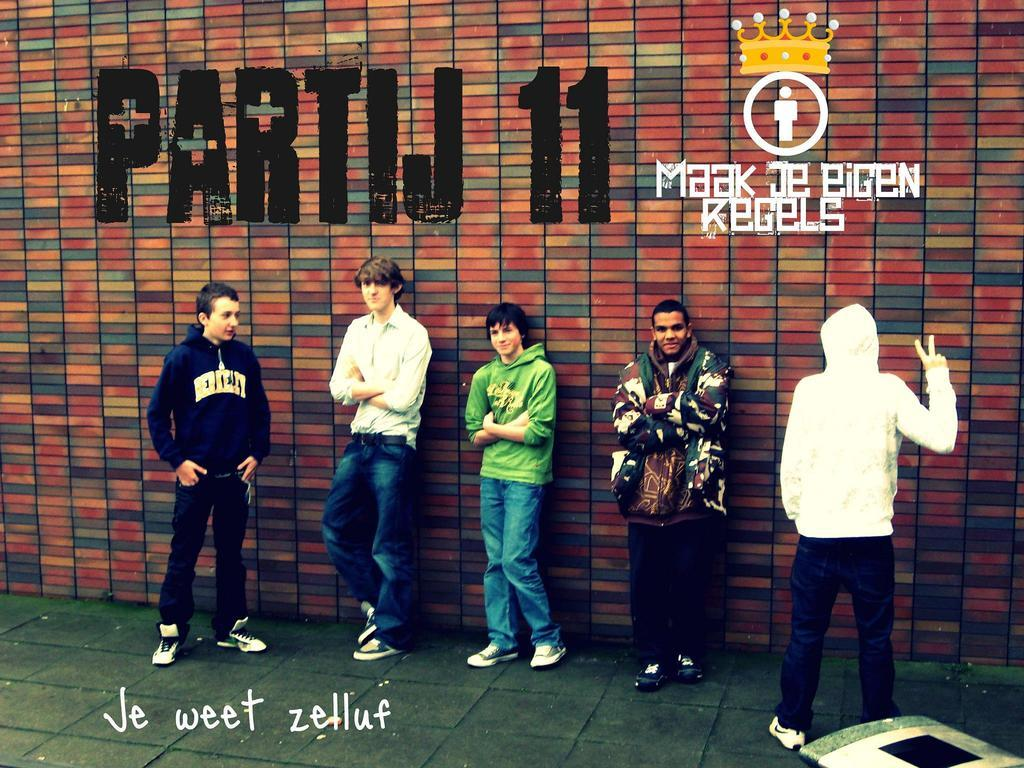How many people are present in the image? There are five men standing in the image. What is the background element in the image? There is a wall in the image. Is there any additional information about the image itself? Yes, there is a watermark on the image. Where is the watermark located? The watermark is located at the bottom right corner of the image. What can be seen besides the men and the wall? There is an object visible in the image. Can you describe the ghost that is interacting with the men in the image? There is no ghost present in the image; it only features five men, a wall, and an object. How does the fold in the men's clothing affect their appearance in the image? There is no mention of any fold in the men's clothing in the image. 